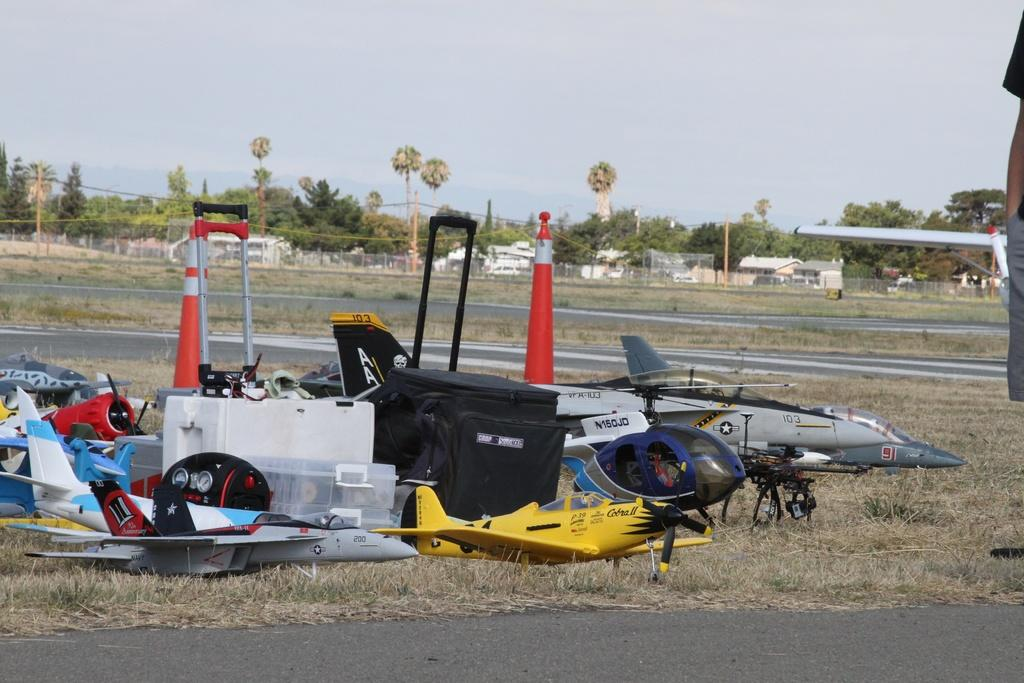<image>
Give a short and clear explanation of the subsequent image. A few plane and a helicopter are on the ground with the ID of N150JD on the helicopter 